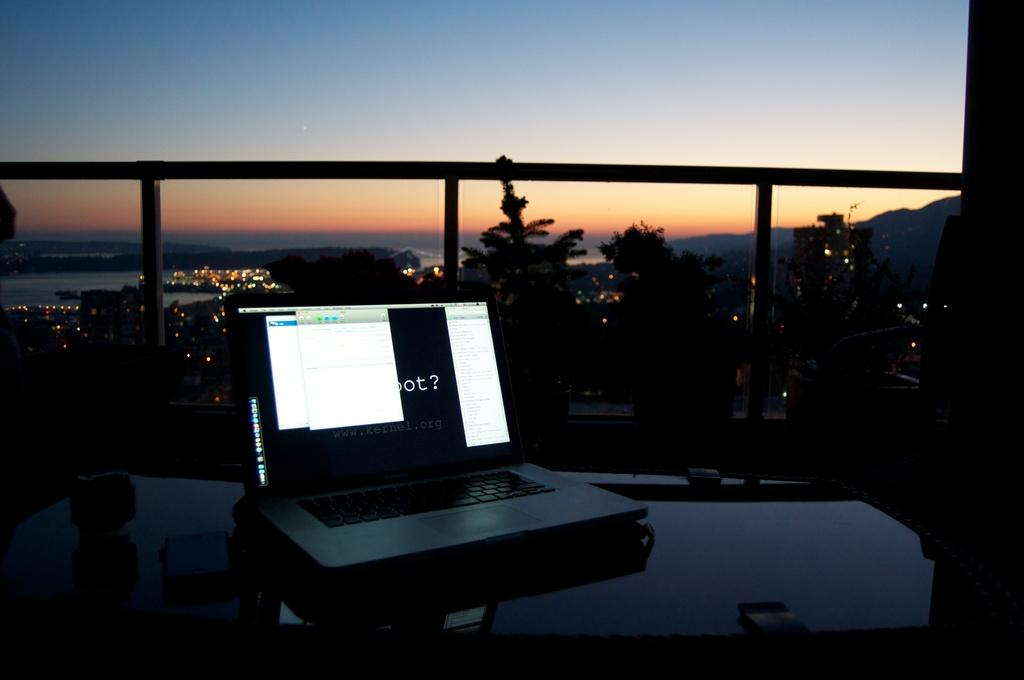<image>
Present a compact description of the photo's key features. A laptop displays an image with www.kernel.org written on it. 